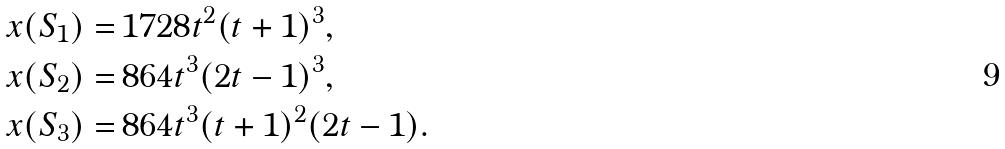Convert formula to latex. <formula><loc_0><loc_0><loc_500><loc_500>x ( S _ { 1 } ) = & \, 1 7 2 8 t ^ { 2 } ( t + 1 ) ^ { 3 } , \\ x ( S _ { 2 } ) = & \, 8 6 4 t ^ { 3 } ( 2 t - 1 ) ^ { 3 } , \\ x ( S _ { 3 } ) = & \, 8 6 4 t ^ { 3 } ( t + 1 ) ^ { 2 } ( 2 t - 1 ) .</formula> 